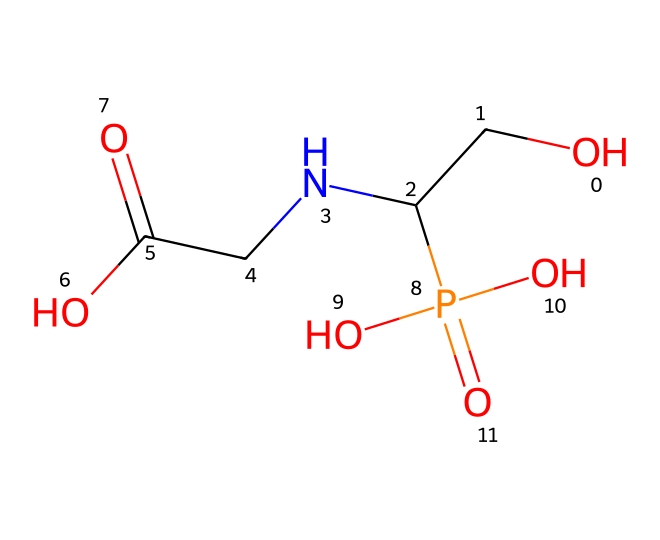How many phosphorus atoms are present in glyphosate? From the SMILES representation, we can identify that there is one 'P' which represents a phosphorus atom.
Answer: one What is the functional group present in glyphosate? The chemical structure shows a phosphate group, which is characterized by the presence of phosphorus bonded to oxygen atoms, specifically indicated by the 'P(=O)(O)(O)' part in the SMILES.
Answer: phosphate How many oxygen atoms are in glyphosate? By examining the SMILES, we can count a total of four oxygen atoms (O) attached to various parts of the molecule.
Answer: four What is the overall charge of glyphosate? The SMILES indicates that there are four oxygen atoms, three of which are part of hydroxyl or negatively charged groups, thus the overall charge is negative.
Answer: negative What type of herbicide is glyphosate? Glyphosate is classified as a systemic herbicide; this classification can be inferred from the presence of the phosphate functional group which is commonly found in herbicides.
Answer: systemic Is glyphosate water-soluble? Glyphosate contains multiple hydroxyl groups and a phosphate, making it polar, which typically indicates that it is water-soluble.
Answer: yes 